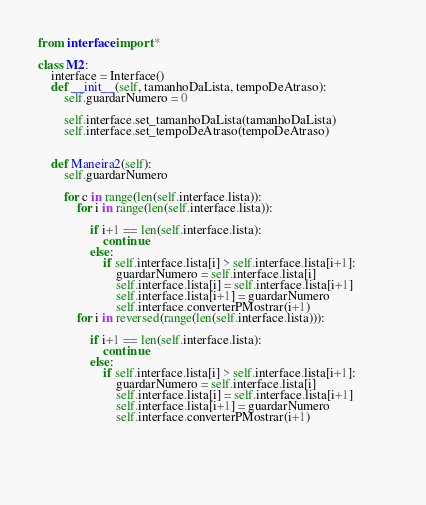Convert code to text. <code><loc_0><loc_0><loc_500><loc_500><_Python_>from interface import *    

class M2:
    interface = Interface()
    def __init__(self, tamanhoDaLista, tempoDeAtraso):
        self.guardarNumero = 0
        
        self.interface.set_tamanhoDaLista(tamanhoDaLista)
        self.interface.set_tempoDeAtraso(tempoDeAtraso)

    
    def Maneira2(self):
        self.guardarNumero
        
        for c in range(len(self.interface.lista)):
            for i in range(len(self.interface.lista)):

                if i+1 == len(self.interface.lista):
                    continue
                else:
                    if self.interface.lista[i] > self.interface.lista[i+1]:
                        guardarNumero = self.interface.lista[i]
                        self.interface.lista[i] = self.interface.lista[i+1]
                        self.interface.lista[i+1] = guardarNumero
                        self.interface.converterPMostrar(i+1)
            for i in reversed(range(len(self.interface.lista))):

                if i+1 == len(self.interface.lista):
                    continue
                else:
                    if self.interface.lista[i] > self.interface.lista[i+1]:
                        guardarNumero = self.interface.lista[i]
                        self.interface.lista[i] = self.interface.lista[i+1]
                        self.interface.lista[i+1] = guardarNumero
                        self.interface.converterPMostrar(i+1)                        
 
            
            
            </code> 